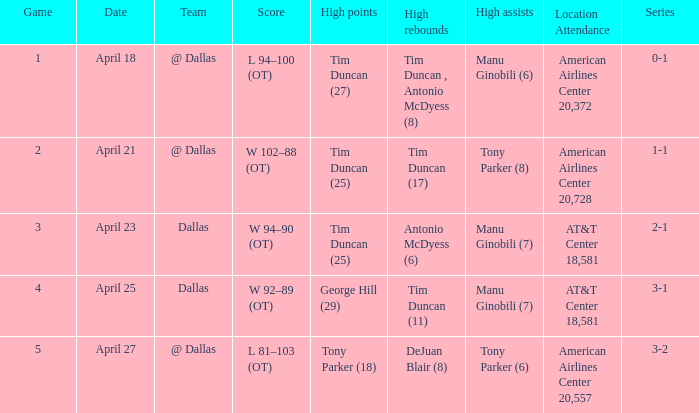When 0-1 is the series who has the highest amount of assists? Manu Ginobili (6). 